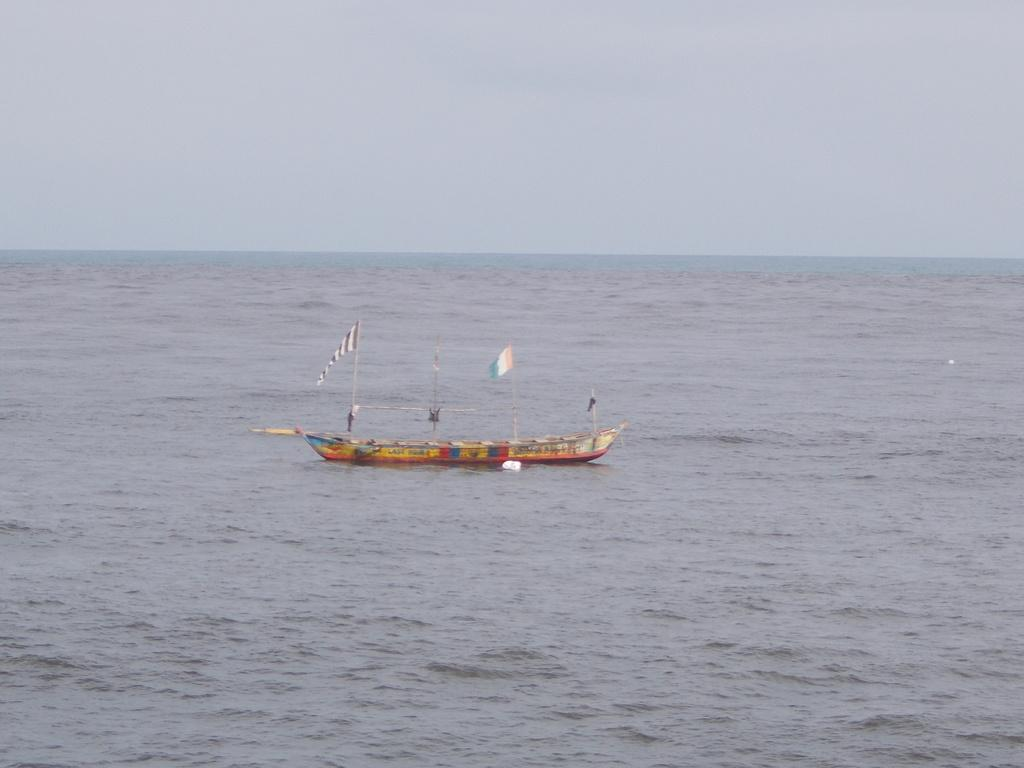What is in the water in the image? There is a boat in the water in the image. What is on the boat? There are flags on the boat. How many passengers are on the boat, and what type of calculator are they using? There is no information about passengers or calculators in the image; it only shows a boat with flags. 